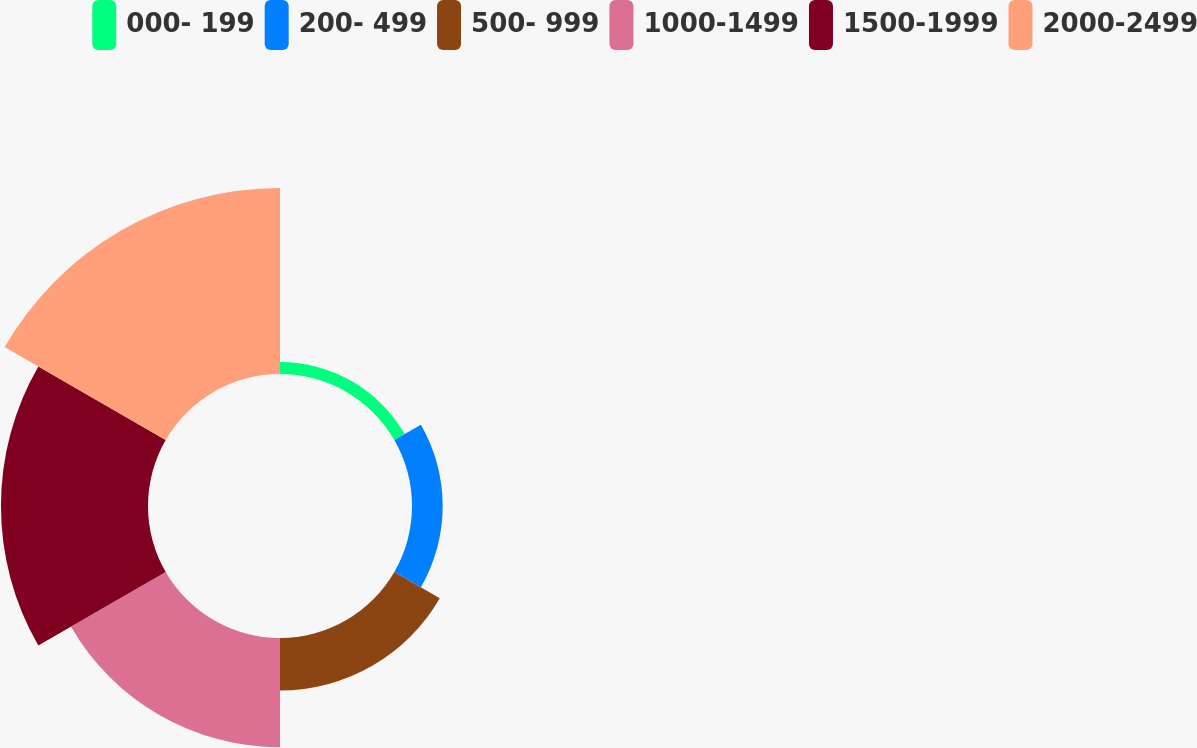Convert chart. <chart><loc_0><loc_0><loc_500><loc_500><pie_chart><fcel>000- 199<fcel>200- 499<fcel>500- 999<fcel>1000-1499<fcel>1500-1999<fcel>2000-2499<nl><fcel>2.22%<fcel>5.71%<fcel>9.77%<fcel>20.34%<fcel>27.36%<fcel>34.61%<nl></chart> 